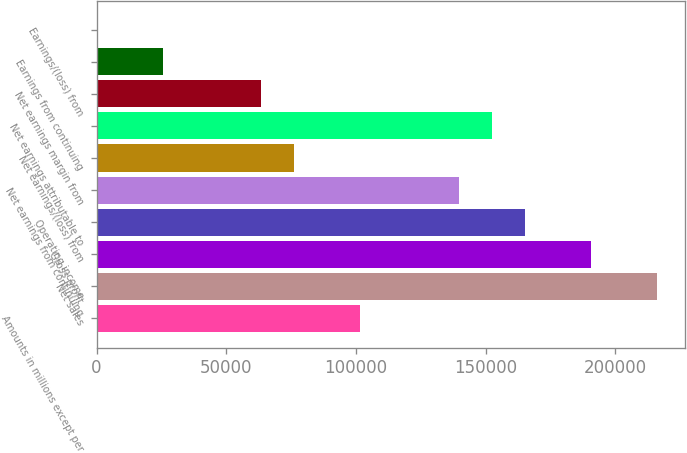Convert chart. <chart><loc_0><loc_0><loc_500><loc_500><bar_chart><fcel>Amounts in millions except per<fcel>Net sales<fcel>Gross profit<fcel>Operating income<fcel>Net earnings from continuing<fcel>Net earnings/(loss) from<fcel>Net earnings attributable to<fcel>Net earnings margin from<fcel>Earnings from continuing<fcel>Earnings/(loss) from<nl><fcel>101709<fcel>216131<fcel>190704<fcel>165277<fcel>139850<fcel>76281.7<fcel>152563<fcel>63568.1<fcel>25427.4<fcel>0.21<nl></chart> 